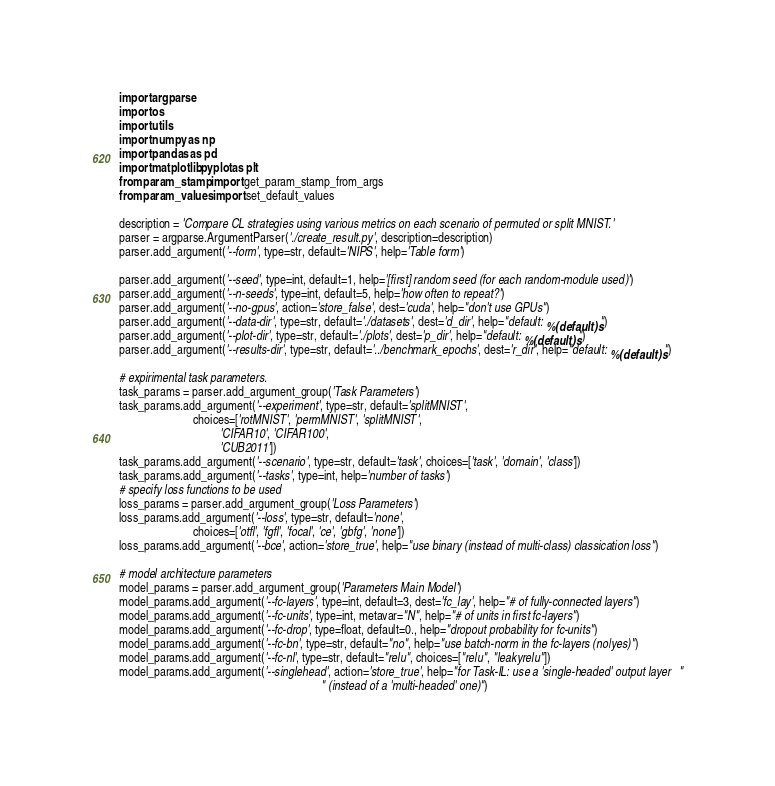<code> <loc_0><loc_0><loc_500><loc_500><_Python_>import argparse
import os
import utils
import numpy as np
import pandas as pd
import matplotlib.pyplot as plt
from param_stamp import get_param_stamp_from_args
from param_values import set_default_values

description = 'Compare CL strategies using various metrics on each scenario of permuted or split MNIST.'
parser = argparse.ArgumentParser('./create_result.py', description=description)
parser.add_argument('--form', type=str, default='NIPS', help='Table form')

parser.add_argument('--seed', type=int, default=1, help='[first] random seed (for each random-module used)')
parser.add_argument('--n-seeds', type=int, default=5, help='how often to repeat?')
parser.add_argument('--no-gpus', action='store_false', dest='cuda', help="don't use GPUs")
parser.add_argument('--data-dir', type=str, default='./datasets', dest='d_dir', help="default: %(default)s")
parser.add_argument('--plot-dir', type=str, default='./plots', dest='p_dir', help="default: %(default)s")
parser.add_argument('--results-dir', type=str, default='../benchmark_epochs', dest='r_dir', help="default: %(default)s")

# expirimental task parameters.
task_params = parser.add_argument_group('Task Parameters')
task_params.add_argument('--experiment', type=str, default='splitMNIST',
                         choices=['rotMNIST', 'permMNIST', 'splitMNIST',
                                  'CIFAR10', 'CIFAR100',
                                  'CUB2011'])
task_params.add_argument('--scenario', type=str, default='task', choices=['task', 'domain', 'class'])
task_params.add_argument('--tasks', type=int, help='number of tasks')
# specify loss functions to be used
loss_params = parser.add_argument_group('Loss Parameters')
loss_params.add_argument('--loss', type=str, default='none',
                         choices=['otfl', 'fgfl', 'focal', 'ce', 'gbfg', 'none'])
loss_params.add_argument('--bce', action='store_true', help="use binary (instead of multi-class) classication loss")

# model architecture parameters
model_params = parser.add_argument_group('Parameters Main Model')
model_params.add_argument('--fc-layers', type=int, default=3, dest='fc_lay', help="# of fully-connected layers")
model_params.add_argument('--fc-units', type=int, metavar="N", help="# of units in first fc-layers")
model_params.add_argument('--fc-drop', type=float, default=0., help="dropout probability for fc-units")
model_params.add_argument('--fc-bn', type=str, default="no", help="use batch-norm in the fc-layers (no|yes)")
model_params.add_argument('--fc-nl', type=str, default="relu", choices=["relu", "leakyrelu"])
model_params.add_argument('--singlehead', action='store_true', help="for Task-IL: use a 'single-headed' output layer   "
                                                                    " (instead of a 'multi-headed' one)")</code> 